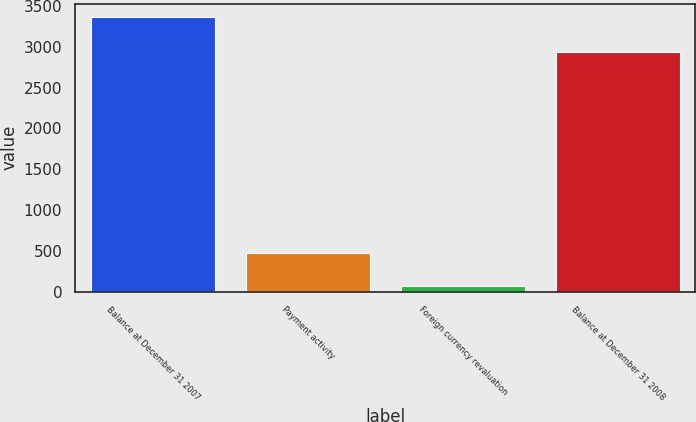Convert chart. <chart><loc_0><loc_0><loc_500><loc_500><bar_chart><fcel>Balance at December 31 2007<fcel>Payment activity<fcel>Foreign currency revaluation<fcel>Balance at December 31 2008<nl><fcel>3360<fcel>470<fcel>67<fcel>2939<nl></chart> 